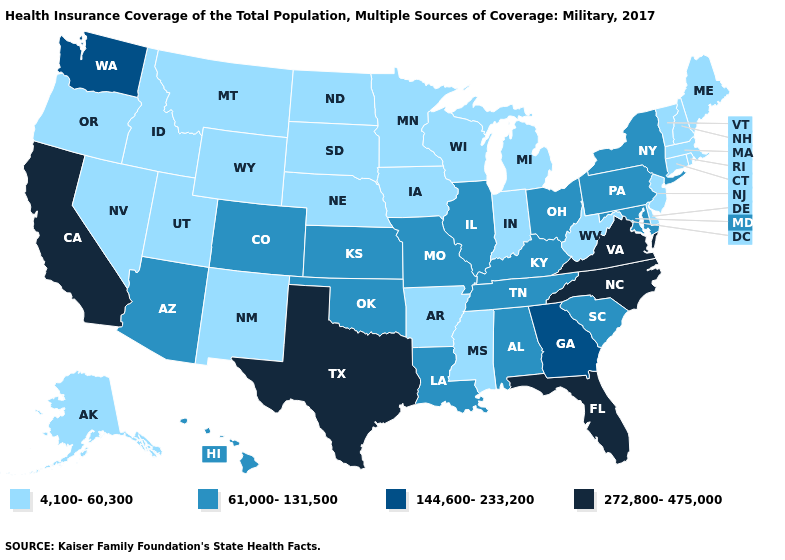Is the legend a continuous bar?
Concise answer only. No. What is the highest value in the USA?
Answer briefly. 272,800-475,000. How many symbols are there in the legend?
Keep it brief. 4. Among the states that border Washington , which have the lowest value?
Quick response, please. Idaho, Oregon. Which states have the lowest value in the USA?
Quick response, please. Alaska, Arkansas, Connecticut, Delaware, Idaho, Indiana, Iowa, Maine, Massachusetts, Michigan, Minnesota, Mississippi, Montana, Nebraska, Nevada, New Hampshire, New Jersey, New Mexico, North Dakota, Oregon, Rhode Island, South Dakota, Utah, Vermont, West Virginia, Wisconsin, Wyoming. What is the value of Illinois?
Write a very short answer. 61,000-131,500. Does South Dakota have the lowest value in the MidWest?
Answer briefly. Yes. Which states have the lowest value in the USA?
Keep it brief. Alaska, Arkansas, Connecticut, Delaware, Idaho, Indiana, Iowa, Maine, Massachusetts, Michigan, Minnesota, Mississippi, Montana, Nebraska, Nevada, New Hampshire, New Jersey, New Mexico, North Dakota, Oregon, Rhode Island, South Dakota, Utah, Vermont, West Virginia, Wisconsin, Wyoming. Name the states that have a value in the range 61,000-131,500?
Write a very short answer. Alabama, Arizona, Colorado, Hawaii, Illinois, Kansas, Kentucky, Louisiana, Maryland, Missouri, New York, Ohio, Oklahoma, Pennsylvania, South Carolina, Tennessee. Does Delaware have the highest value in the USA?
Write a very short answer. No. What is the value of Massachusetts?
Answer briefly. 4,100-60,300. Does Ohio have a lower value than Washington?
Answer briefly. Yes. What is the lowest value in states that border Oklahoma?
Short answer required. 4,100-60,300. What is the value of Indiana?
Be succinct. 4,100-60,300. What is the highest value in states that border Nebraska?
Quick response, please. 61,000-131,500. 